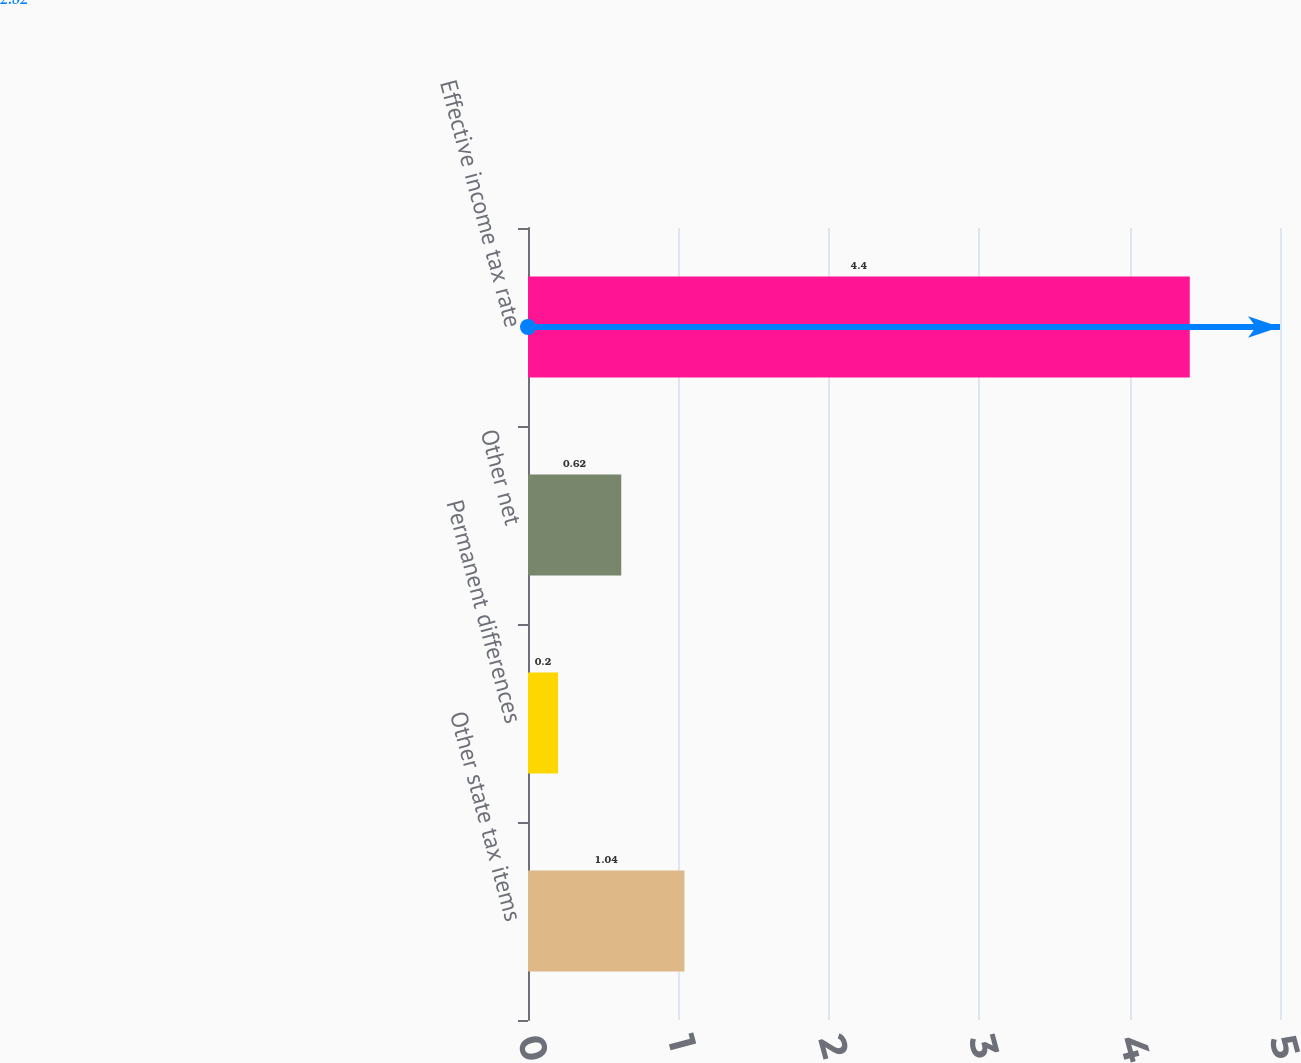Convert chart. <chart><loc_0><loc_0><loc_500><loc_500><bar_chart><fcel>Other state tax items<fcel>Permanent differences<fcel>Other net<fcel>Effective income tax rate<nl><fcel>1.04<fcel>0.2<fcel>0.62<fcel>4.4<nl></chart> 